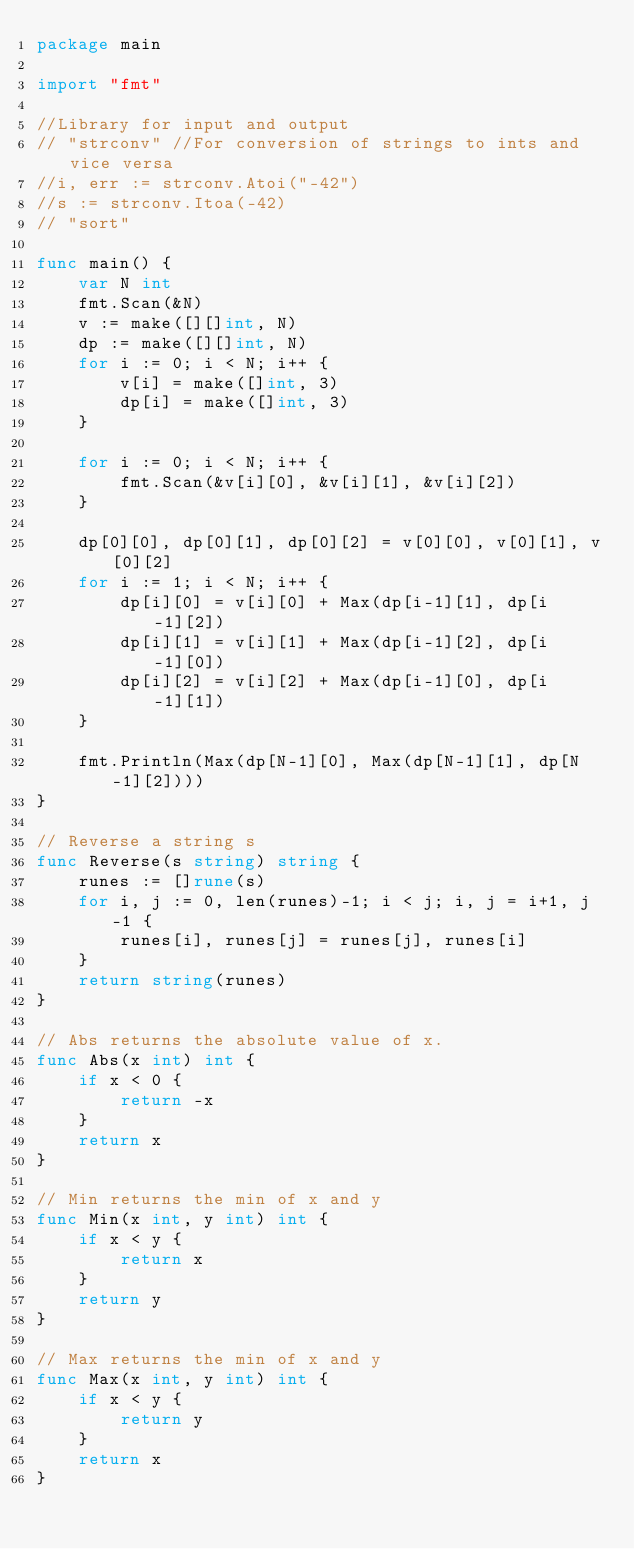<code> <loc_0><loc_0><loc_500><loc_500><_Go_>package main

import "fmt"

//Library for input and output
// "strconv" //For conversion of strings to ints and vice versa
//i, err := strconv.Atoi("-42")
//s := strconv.Itoa(-42)
// "sort"

func main() {
	var N int
	fmt.Scan(&N)
	v := make([][]int, N)
	dp := make([][]int, N)
	for i := 0; i < N; i++ {
		v[i] = make([]int, 3)
		dp[i] = make([]int, 3)
	}

	for i := 0; i < N; i++ {
		fmt.Scan(&v[i][0], &v[i][1], &v[i][2])
	}

	dp[0][0], dp[0][1], dp[0][2] = v[0][0], v[0][1], v[0][2]
	for i := 1; i < N; i++ {
		dp[i][0] = v[i][0] + Max(dp[i-1][1], dp[i-1][2])
		dp[i][1] = v[i][1] + Max(dp[i-1][2], dp[i-1][0])
		dp[i][2] = v[i][2] + Max(dp[i-1][0], dp[i-1][1])
	}

	fmt.Println(Max(dp[N-1][0], Max(dp[N-1][1], dp[N-1][2])))
}

// Reverse a string s
func Reverse(s string) string {
	runes := []rune(s)
	for i, j := 0, len(runes)-1; i < j; i, j = i+1, j-1 {
		runes[i], runes[j] = runes[j], runes[i]
	}
	return string(runes)
}

// Abs returns the absolute value of x.
func Abs(x int) int {
	if x < 0 {
		return -x
	}
	return x
}

// Min returns the min of x and y
func Min(x int, y int) int {
	if x < y {
		return x
	}
	return y
}

// Max returns the min of x and y
func Max(x int, y int) int {
	if x < y {
		return y
	}
	return x
}
</code> 